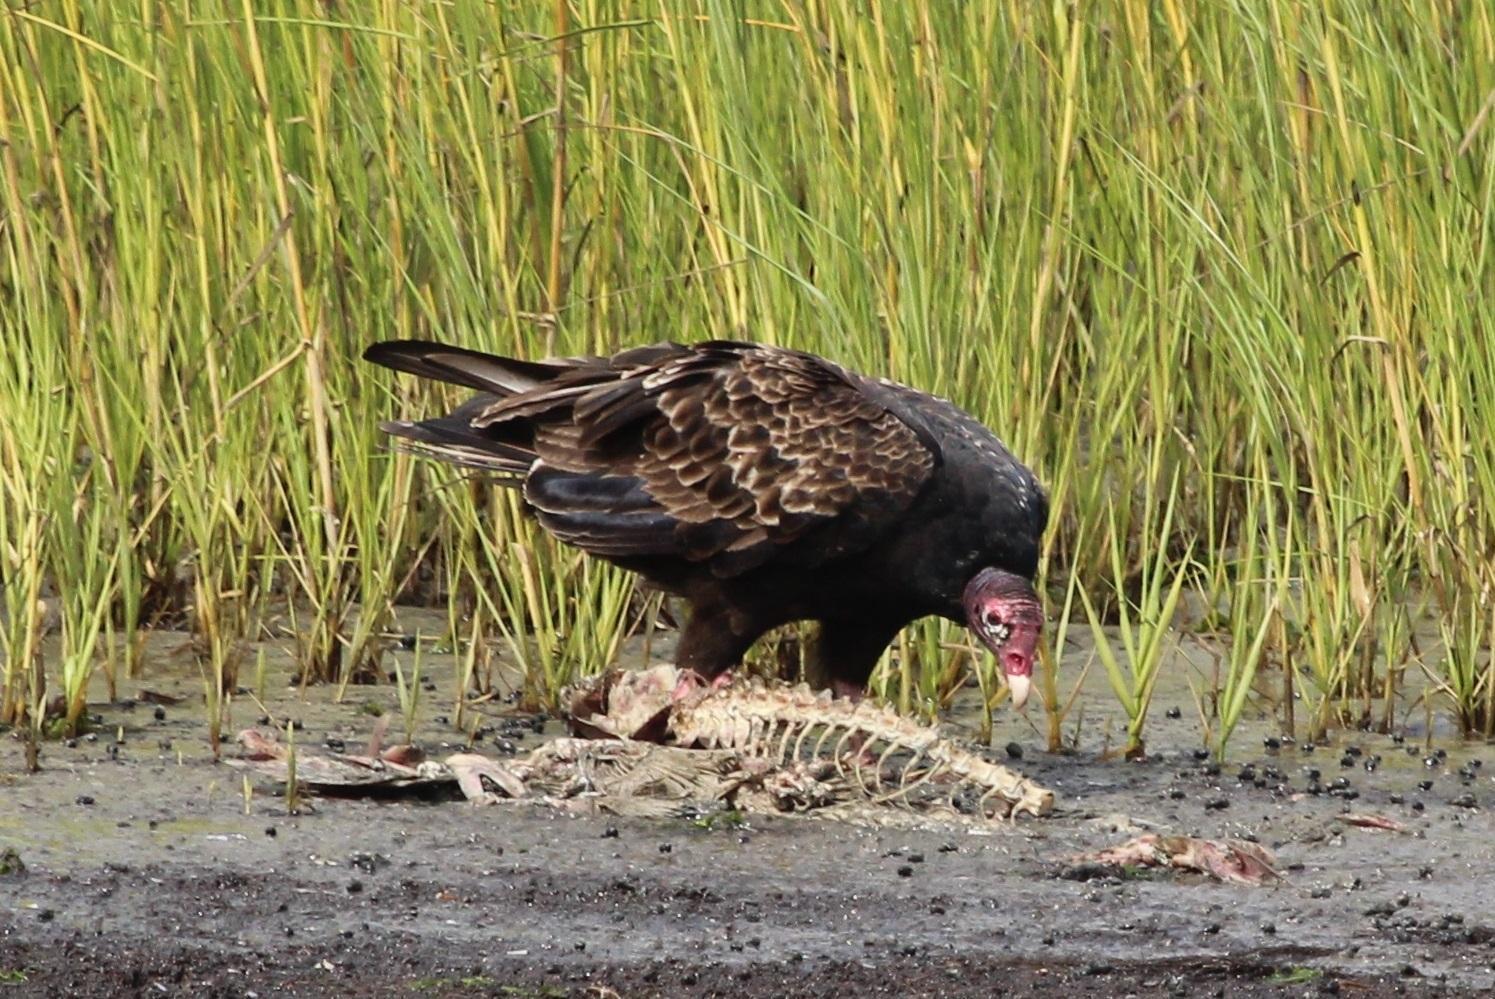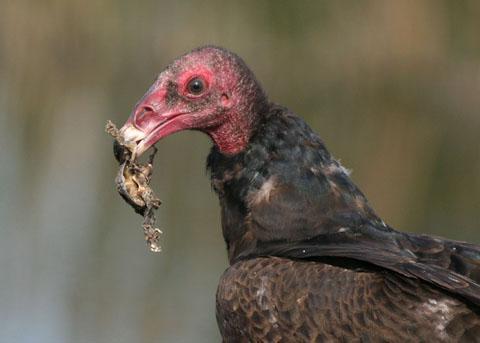The first image is the image on the left, the second image is the image on the right. Evaluate the accuracy of this statement regarding the images: "There are two vultures eating in the images.". Is it true? Answer yes or no. Yes. The first image is the image on the left, the second image is the image on the right. For the images displayed, is the sentence "in the right side pic the bird has something it its mouth" factually correct? Answer yes or no. Yes. 